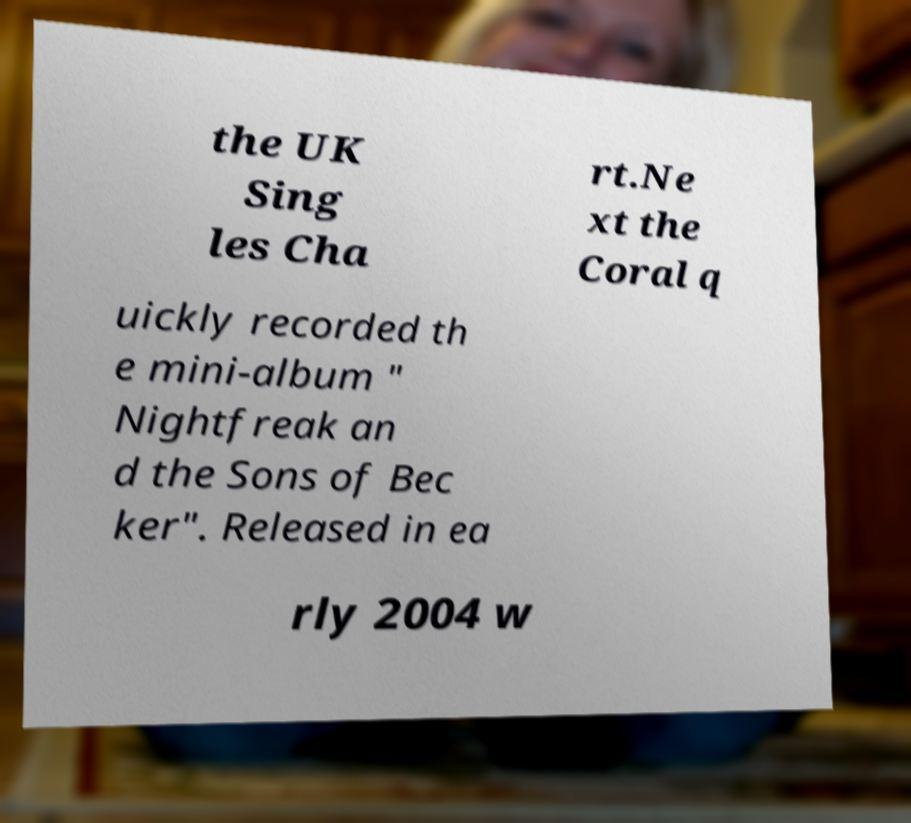Can you accurately transcribe the text from the provided image for me? the UK Sing les Cha rt.Ne xt the Coral q uickly recorded th e mini-album " Nightfreak an d the Sons of Bec ker". Released in ea rly 2004 w 